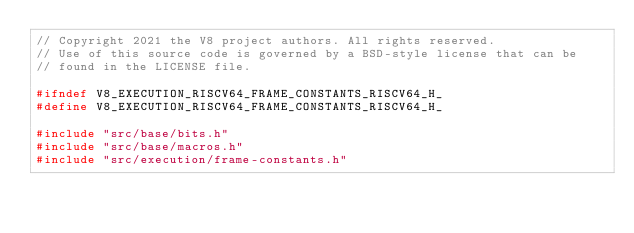Convert code to text. <code><loc_0><loc_0><loc_500><loc_500><_C_>// Copyright 2021 the V8 project authors. All rights reserved.
// Use of this source code is governed by a BSD-style license that can be
// found in the LICENSE file.

#ifndef V8_EXECUTION_RISCV64_FRAME_CONSTANTS_RISCV64_H_
#define V8_EXECUTION_RISCV64_FRAME_CONSTANTS_RISCV64_H_

#include "src/base/bits.h"
#include "src/base/macros.h"
#include "src/execution/frame-constants.h"</code> 